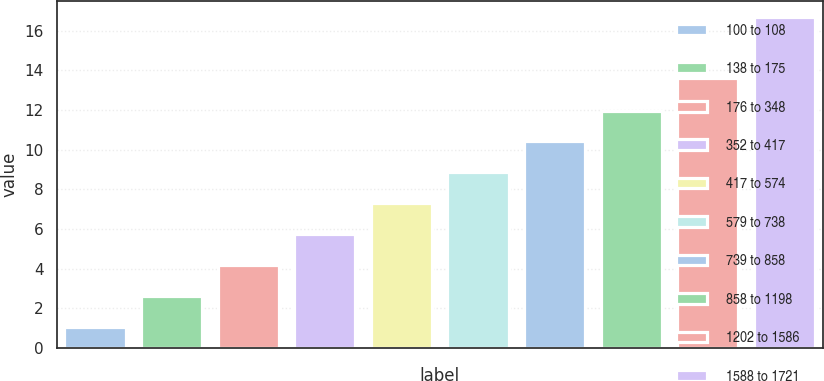Convert chart to OTSL. <chart><loc_0><loc_0><loc_500><loc_500><bar_chart><fcel>100 to 108<fcel>138 to 175<fcel>176 to 348<fcel>352 to 417<fcel>417 to 574<fcel>579 to 738<fcel>739 to 858<fcel>858 to 1198<fcel>1202 to 1586<fcel>1588 to 1721<nl><fcel>1.05<fcel>2.61<fcel>4.17<fcel>5.73<fcel>7.29<fcel>8.85<fcel>10.41<fcel>11.97<fcel>13.63<fcel>16.67<nl></chart> 